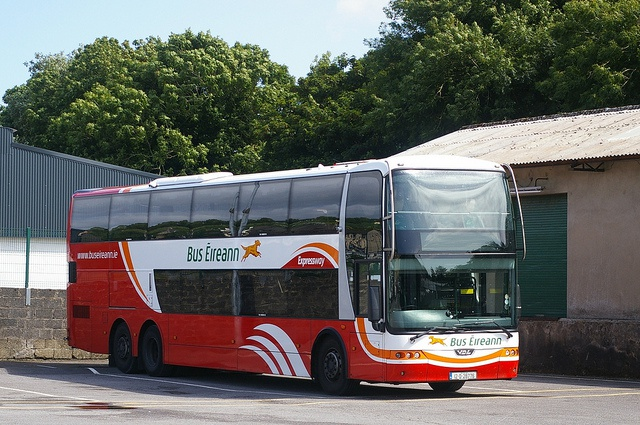Describe the objects in this image and their specific colors. I can see bus in lightblue, black, maroon, gray, and lightgray tones in this image. 